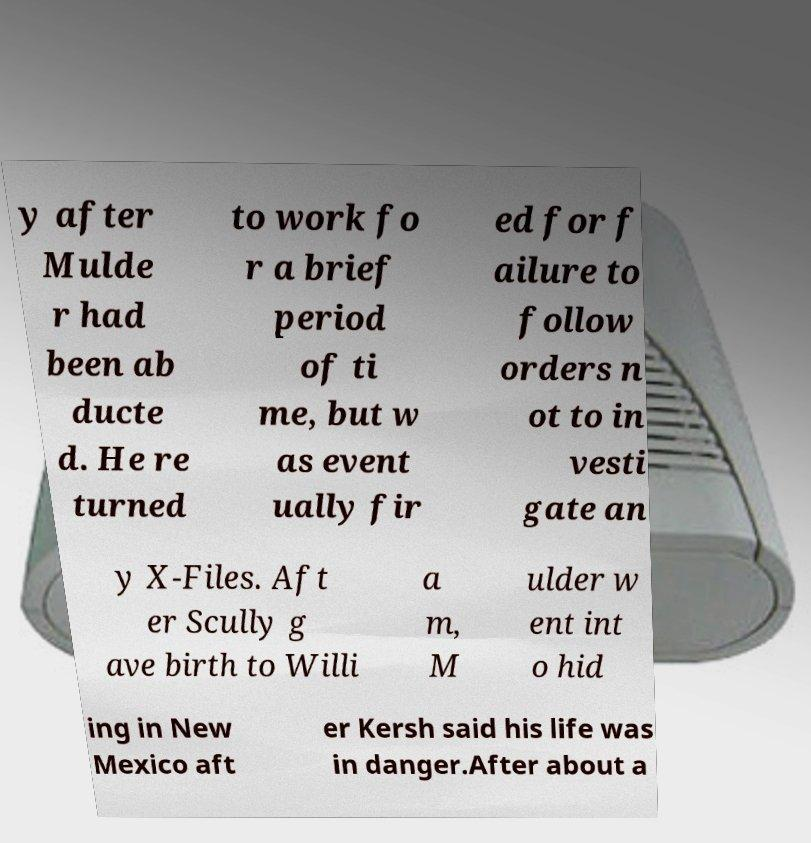For documentation purposes, I need the text within this image transcribed. Could you provide that? y after Mulde r had been ab ducte d. He re turned to work fo r a brief period of ti me, but w as event ually fir ed for f ailure to follow orders n ot to in vesti gate an y X-Files. Aft er Scully g ave birth to Willi a m, M ulder w ent int o hid ing in New Mexico aft er Kersh said his life was in danger.After about a 